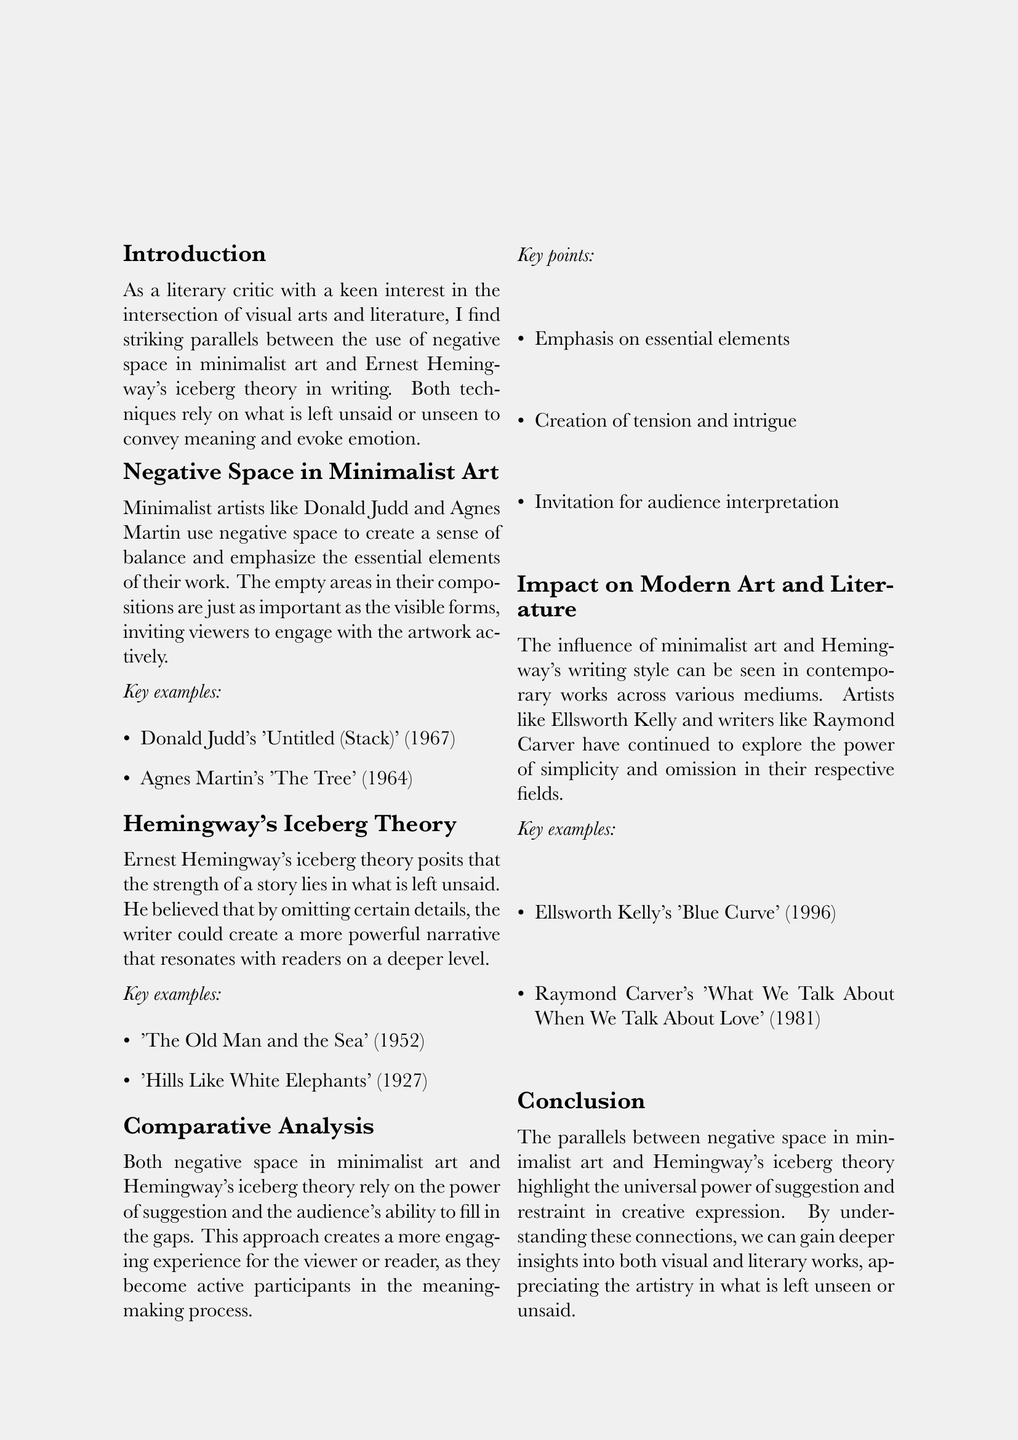what is the title of the memo? The title of the memo is presented at the top and encapsulates the primary focus, which is the comparison of two artistic forms.
Answer: The Unseen in Art and Literature who are two minimalist artists mentioned in the document? The document lists specific minimalist artists to illustrate the point, including Donald Judd and Agnes Martin.
Answer: Donald Judd and Agnes Martin what does Hemingway's iceberg theory emphasize? The document states that Hemingway's theory highlights what is intentionally omitted to craft a deeper narrative.
Answer: What is left unsaid name one example of Hemingway's work cited in the document. The document provides specific examples of Hemingway's work that exemplify his iceberg theory.
Answer: The Old Man and the Sea which artist is associated with the work 'Blue Curve'? The document specifies an artist linked to a particular minimalist piece to show contemporary relevance in the discussion.
Answer: Ellsworth Kelly how many key figures are listed in the document? The document lists several key figures to support the discussions throughout the memo.
Answer: Five what is a key point of comparative analysis between art and literature mentioned? The document outlines important aspects that both mediums share, demonstrating their intersection.
Answer: Invitation for audience interpretation what publication is suggested for further reading about Hemingway? The document includes references that provide additional insights into Hemingway's artistic approach and philosophy.
Answer: Ernest Hemingway: The Art of Fiction No. 21 